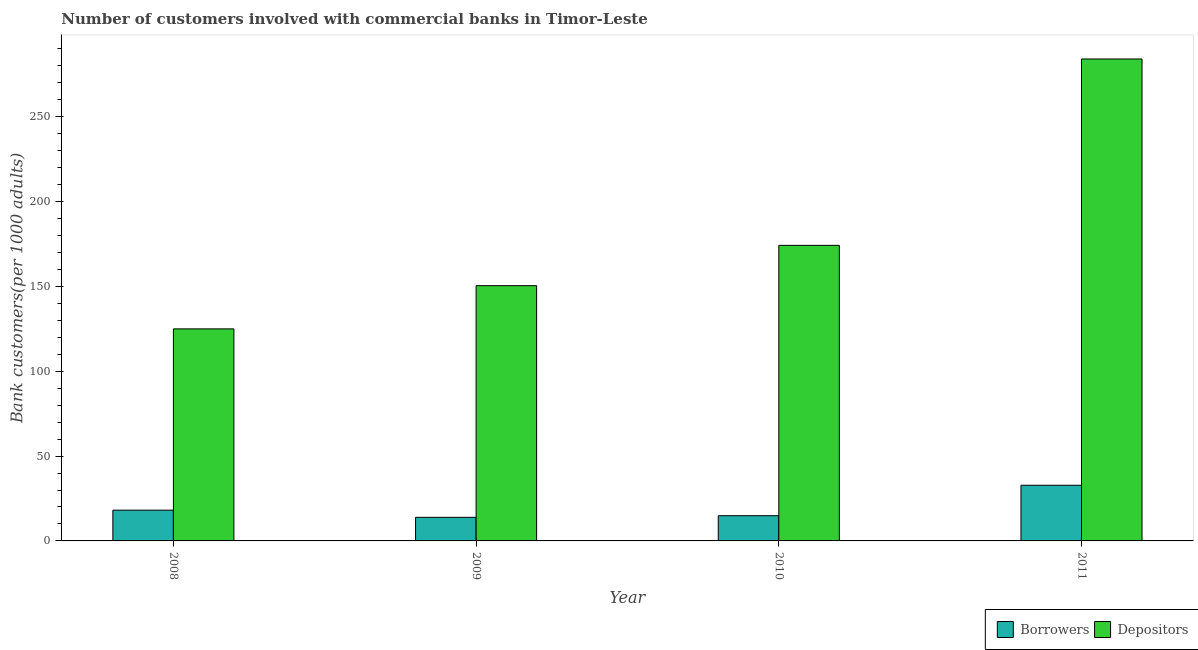How many different coloured bars are there?
Make the answer very short. 2. Are the number of bars per tick equal to the number of legend labels?
Keep it short and to the point. Yes. Are the number of bars on each tick of the X-axis equal?
Your response must be concise. Yes. How many bars are there on the 3rd tick from the right?
Give a very brief answer. 2. In how many cases, is the number of bars for a given year not equal to the number of legend labels?
Keep it short and to the point. 0. What is the number of borrowers in 2009?
Ensure brevity in your answer.  13.9. Across all years, what is the maximum number of borrowers?
Your answer should be compact. 32.81. Across all years, what is the minimum number of borrowers?
Give a very brief answer. 13.9. In which year was the number of borrowers minimum?
Your response must be concise. 2009. What is the total number of borrowers in the graph?
Keep it short and to the point. 79.71. What is the difference between the number of borrowers in 2008 and that in 2009?
Give a very brief answer. 4.22. What is the difference between the number of borrowers in 2009 and the number of depositors in 2008?
Offer a terse response. -4.22. What is the average number of borrowers per year?
Your answer should be very brief. 19.93. In the year 2011, what is the difference between the number of depositors and number of borrowers?
Keep it short and to the point. 0. What is the ratio of the number of borrowers in 2008 to that in 2009?
Offer a very short reply. 1.3. Is the number of depositors in 2008 less than that in 2011?
Your answer should be compact. Yes. What is the difference between the highest and the second highest number of borrowers?
Your answer should be very brief. 14.69. What is the difference between the highest and the lowest number of borrowers?
Your response must be concise. 18.91. Is the sum of the number of borrowers in 2008 and 2009 greater than the maximum number of depositors across all years?
Offer a very short reply. No. What does the 1st bar from the left in 2008 represents?
Your response must be concise. Borrowers. What does the 1st bar from the right in 2009 represents?
Your response must be concise. Depositors. Are all the bars in the graph horizontal?
Provide a succinct answer. No. What is the difference between two consecutive major ticks on the Y-axis?
Provide a short and direct response. 50. Are the values on the major ticks of Y-axis written in scientific E-notation?
Keep it short and to the point. No. Does the graph contain any zero values?
Your answer should be very brief. No. Where does the legend appear in the graph?
Your response must be concise. Bottom right. How are the legend labels stacked?
Your answer should be very brief. Horizontal. What is the title of the graph?
Ensure brevity in your answer.  Number of customers involved with commercial banks in Timor-Leste. Does "Net savings(excluding particulate emission damage)" appear as one of the legend labels in the graph?
Your response must be concise. No. What is the label or title of the X-axis?
Provide a short and direct response. Year. What is the label or title of the Y-axis?
Offer a very short reply. Bank customers(per 1000 adults). What is the Bank customers(per 1000 adults) of Borrowers in 2008?
Keep it short and to the point. 18.13. What is the Bank customers(per 1000 adults) in Depositors in 2008?
Make the answer very short. 124.98. What is the Bank customers(per 1000 adults) of Borrowers in 2009?
Your answer should be very brief. 13.9. What is the Bank customers(per 1000 adults) in Depositors in 2009?
Offer a very short reply. 150.45. What is the Bank customers(per 1000 adults) in Borrowers in 2010?
Keep it short and to the point. 14.87. What is the Bank customers(per 1000 adults) in Depositors in 2010?
Make the answer very short. 174.21. What is the Bank customers(per 1000 adults) in Borrowers in 2011?
Your answer should be very brief. 32.81. What is the Bank customers(per 1000 adults) of Depositors in 2011?
Ensure brevity in your answer.  284.07. Across all years, what is the maximum Bank customers(per 1000 adults) of Borrowers?
Your answer should be compact. 32.81. Across all years, what is the maximum Bank customers(per 1000 adults) in Depositors?
Provide a short and direct response. 284.07. Across all years, what is the minimum Bank customers(per 1000 adults) of Borrowers?
Offer a terse response. 13.9. Across all years, what is the minimum Bank customers(per 1000 adults) in Depositors?
Keep it short and to the point. 124.98. What is the total Bank customers(per 1000 adults) in Borrowers in the graph?
Your answer should be very brief. 79.71. What is the total Bank customers(per 1000 adults) of Depositors in the graph?
Your answer should be very brief. 733.72. What is the difference between the Bank customers(per 1000 adults) of Borrowers in 2008 and that in 2009?
Ensure brevity in your answer.  4.22. What is the difference between the Bank customers(per 1000 adults) in Depositors in 2008 and that in 2009?
Your answer should be very brief. -25.47. What is the difference between the Bank customers(per 1000 adults) in Borrowers in 2008 and that in 2010?
Your answer should be very brief. 3.25. What is the difference between the Bank customers(per 1000 adults) of Depositors in 2008 and that in 2010?
Keep it short and to the point. -49.23. What is the difference between the Bank customers(per 1000 adults) of Borrowers in 2008 and that in 2011?
Your answer should be very brief. -14.69. What is the difference between the Bank customers(per 1000 adults) in Depositors in 2008 and that in 2011?
Your answer should be compact. -159.09. What is the difference between the Bank customers(per 1000 adults) in Borrowers in 2009 and that in 2010?
Your response must be concise. -0.97. What is the difference between the Bank customers(per 1000 adults) in Depositors in 2009 and that in 2010?
Make the answer very short. -23.76. What is the difference between the Bank customers(per 1000 adults) in Borrowers in 2009 and that in 2011?
Provide a succinct answer. -18.91. What is the difference between the Bank customers(per 1000 adults) of Depositors in 2009 and that in 2011?
Ensure brevity in your answer.  -133.62. What is the difference between the Bank customers(per 1000 adults) of Borrowers in 2010 and that in 2011?
Provide a short and direct response. -17.94. What is the difference between the Bank customers(per 1000 adults) of Depositors in 2010 and that in 2011?
Offer a terse response. -109.86. What is the difference between the Bank customers(per 1000 adults) in Borrowers in 2008 and the Bank customers(per 1000 adults) in Depositors in 2009?
Your response must be concise. -132.33. What is the difference between the Bank customers(per 1000 adults) of Borrowers in 2008 and the Bank customers(per 1000 adults) of Depositors in 2010?
Your response must be concise. -156.09. What is the difference between the Bank customers(per 1000 adults) in Borrowers in 2008 and the Bank customers(per 1000 adults) in Depositors in 2011?
Keep it short and to the point. -265.95. What is the difference between the Bank customers(per 1000 adults) of Borrowers in 2009 and the Bank customers(per 1000 adults) of Depositors in 2010?
Make the answer very short. -160.31. What is the difference between the Bank customers(per 1000 adults) of Borrowers in 2009 and the Bank customers(per 1000 adults) of Depositors in 2011?
Offer a very short reply. -270.17. What is the difference between the Bank customers(per 1000 adults) of Borrowers in 2010 and the Bank customers(per 1000 adults) of Depositors in 2011?
Make the answer very short. -269.2. What is the average Bank customers(per 1000 adults) of Borrowers per year?
Give a very brief answer. 19.93. What is the average Bank customers(per 1000 adults) in Depositors per year?
Provide a succinct answer. 183.43. In the year 2008, what is the difference between the Bank customers(per 1000 adults) in Borrowers and Bank customers(per 1000 adults) in Depositors?
Provide a succinct answer. -106.86. In the year 2009, what is the difference between the Bank customers(per 1000 adults) in Borrowers and Bank customers(per 1000 adults) in Depositors?
Offer a terse response. -136.55. In the year 2010, what is the difference between the Bank customers(per 1000 adults) of Borrowers and Bank customers(per 1000 adults) of Depositors?
Give a very brief answer. -159.34. In the year 2011, what is the difference between the Bank customers(per 1000 adults) of Borrowers and Bank customers(per 1000 adults) of Depositors?
Your answer should be very brief. -251.26. What is the ratio of the Bank customers(per 1000 adults) in Borrowers in 2008 to that in 2009?
Provide a short and direct response. 1.3. What is the ratio of the Bank customers(per 1000 adults) in Depositors in 2008 to that in 2009?
Your answer should be very brief. 0.83. What is the ratio of the Bank customers(per 1000 adults) in Borrowers in 2008 to that in 2010?
Keep it short and to the point. 1.22. What is the ratio of the Bank customers(per 1000 adults) in Depositors in 2008 to that in 2010?
Give a very brief answer. 0.72. What is the ratio of the Bank customers(per 1000 adults) of Borrowers in 2008 to that in 2011?
Your answer should be very brief. 0.55. What is the ratio of the Bank customers(per 1000 adults) of Depositors in 2008 to that in 2011?
Make the answer very short. 0.44. What is the ratio of the Bank customers(per 1000 adults) in Borrowers in 2009 to that in 2010?
Your response must be concise. 0.94. What is the ratio of the Bank customers(per 1000 adults) in Depositors in 2009 to that in 2010?
Your answer should be compact. 0.86. What is the ratio of the Bank customers(per 1000 adults) of Borrowers in 2009 to that in 2011?
Offer a very short reply. 0.42. What is the ratio of the Bank customers(per 1000 adults) of Depositors in 2009 to that in 2011?
Provide a succinct answer. 0.53. What is the ratio of the Bank customers(per 1000 adults) of Borrowers in 2010 to that in 2011?
Ensure brevity in your answer.  0.45. What is the ratio of the Bank customers(per 1000 adults) in Depositors in 2010 to that in 2011?
Offer a terse response. 0.61. What is the difference between the highest and the second highest Bank customers(per 1000 adults) of Borrowers?
Make the answer very short. 14.69. What is the difference between the highest and the second highest Bank customers(per 1000 adults) in Depositors?
Your answer should be very brief. 109.86. What is the difference between the highest and the lowest Bank customers(per 1000 adults) in Borrowers?
Your answer should be very brief. 18.91. What is the difference between the highest and the lowest Bank customers(per 1000 adults) in Depositors?
Your response must be concise. 159.09. 